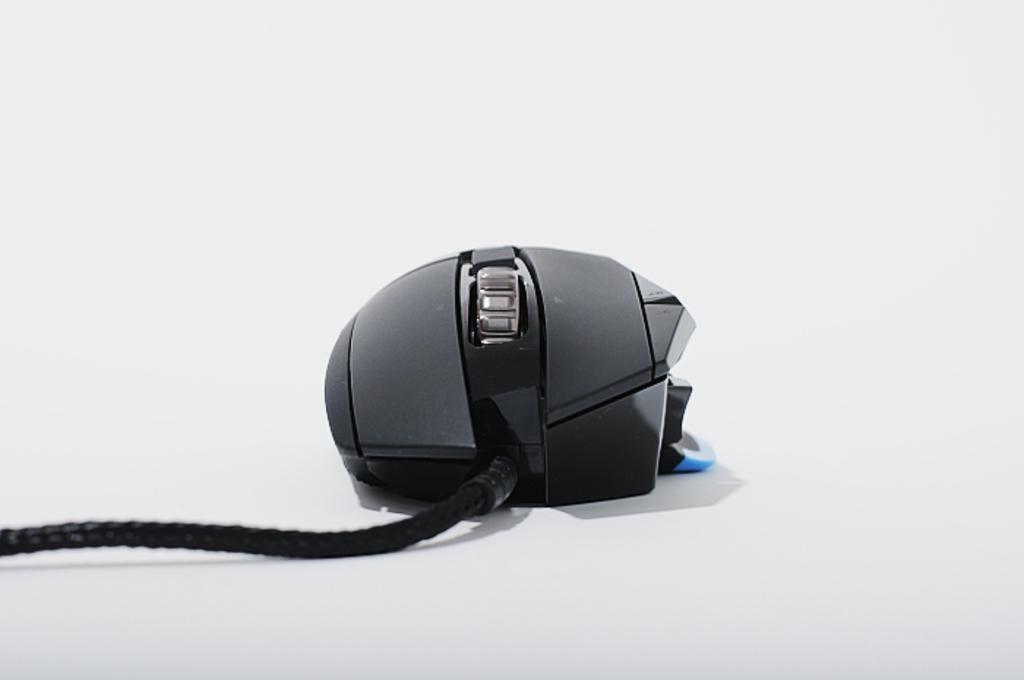What object is the main subject of the image? There is a computer mouse in the image. What is the color of the computer mouse? The computer mouse is black in color. Does the computer mouse have any visible wires? Yes, the computer mouse has a black wire. What is the color of the background in the image? The background of the image is white in color. Where is the grandmother sitting on her throne in the image? There is no grandmother or throne present in the image; it only features a black computer mouse with a wire on a white background. 